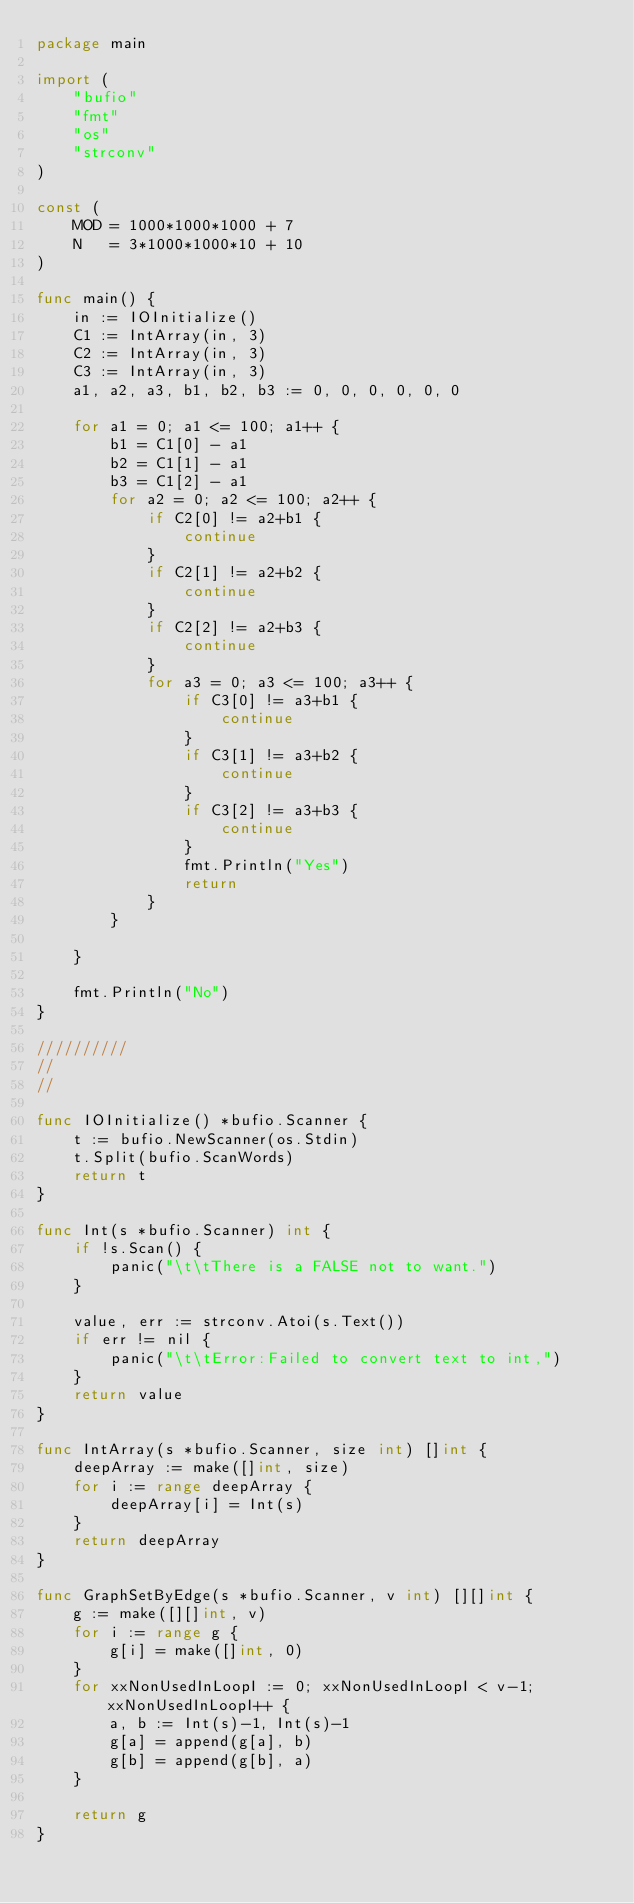<code> <loc_0><loc_0><loc_500><loc_500><_Go_>package main

import (
	"bufio"
	"fmt"
	"os"
	"strconv"
)

const (
	MOD = 1000*1000*1000 + 7
	N   = 3*1000*1000*10 + 10
)

func main() {
	in := IOInitialize()
	C1 := IntArray(in, 3)
	C2 := IntArray(in, 3)
	C3 := IntArray(in, 3)
	a1, a2, a3, b1, b2, b3 := 0, 0, 0, 0, 0, 0

	for a1 = 0; a1 <= 100; a1++ {
		b1 = C1[0] - a1
		b2 = C1[1] - a1
		b3 = C1[2] - a1
		for a2 = 0; a2 <= 100; a2++ {
			if C2[0] != a2+b1 {
				continue
			}
			if C2[1] != a2+b2 {
				continue
			}
			if C2[2] != a2+b3 {
				continue
			}
			for a3 = 0; a3 <= 100; a3++ {
				if C3[0] != a3+b1 {
					continue
				}
				if C3[1] != a3+b2 {
					continue
				}
				if C3[2] != a3+b3 {
					continue
				}
				fmt.Println("Yes")
				return
			}
		}

	}

	fmt.Println("No")
}

//////////
//
//

func IOInitialize() *bufio.Scanner {
	t := bufio.NewScanner(os.Stdin)
	t.Split(bufio.ScanWords)
	return t
}

func Int(s *bufio.Scanner) int {
	if !s.Scan() {
		panic("\t\tThere is a FALSE not to want.")
	}

	value, err := strconv.Atoi(s.Text())
	if err != nil {
		panic("\t\tError:Failed to convert text to int,")
	}
	return value
}

func IntArray(s *bufio.Scanner, size int) []int {
	deepArray := make([]int, size)
	for i := range deepArray {
		deepArray[i] = Int(s)
	}
	return deepArray
}

func GraphSetByEdge(s *bufio.Scanner, v int) [][]int {
	g := make([][]int, v)
	for i := range g {
		g[i] = make([]int, 0)
	}
	for xxNonUsedInLoopI := 0; xxNonUsedInLoopI < v-1; xxNonUsedInLoopI++ {
		a, b := Int(s)-1, Int(s)-1
		g[a] = append(g[a], b)
		g[b] = append(g[b], a)
	}

	return g
}
</code> 